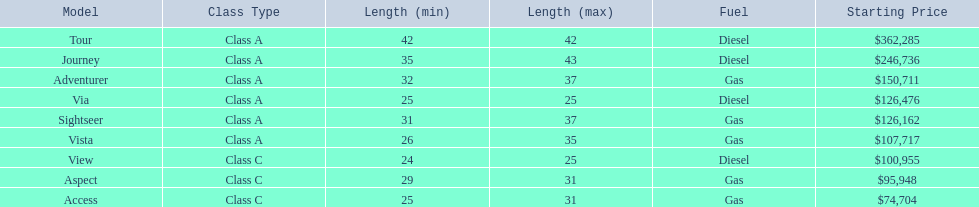What are all the class a models of the winnebago industries? Tour, Journey, Adventurer, Via, Sightseer, Vista. Of those class a models, which has the highest starting price? Tour. 